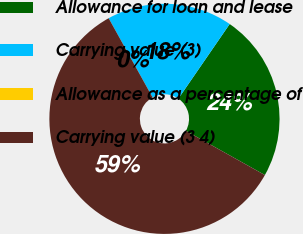Convert chart. <chart><loc_0><loc_0><loc_500><loc_500><pie_chart><fcel>Allowance for loan and lease<fcel>Carrying value (3)<fcel>Allowance as a percentage of<fcel>Carrying value (3 4)<nl><fcel>23.53%<fcel>17.65%<fcel>0.0%<fcel>58.82%<nl></chart> 